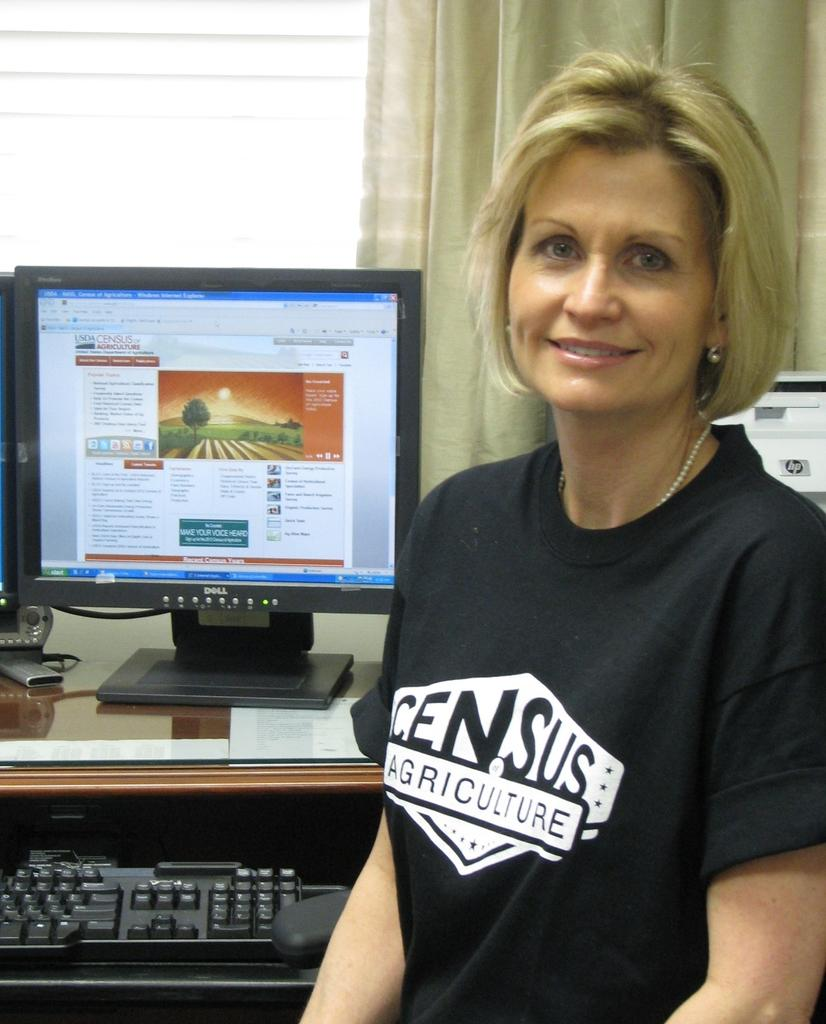<image>
Summarize the visual content of the image. A woman in a Census Agriculture shirt sits in front of a computer. 